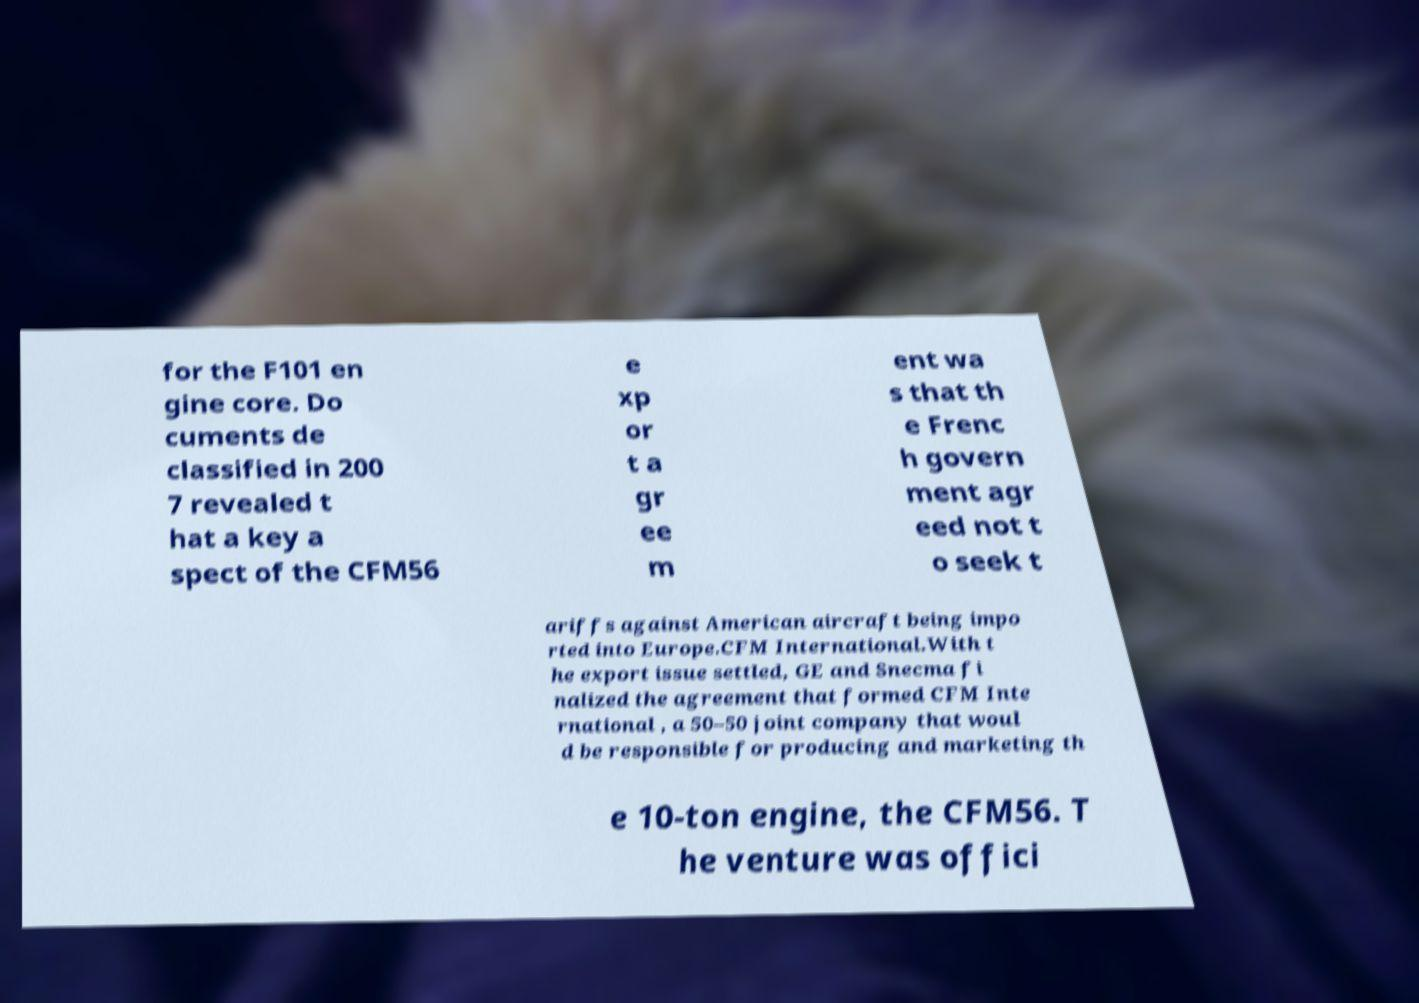Please identify and transcribe the text found in this image. for the F101 en gine core. Do cuments de classified in 200 7 revealed t hat a key a spect of the CFM56 e xp or t a gr ee m ent wa s that th e Frenc h govern ment agr eed not t o seek t ariffs against American aircraft being impo rted into Europe.CFM International.With t he export issue settled, GE and Snecma fi nalized the agreement that formed CFM Inte rnational , a 50–50 joint company that woul d be responsible for producing and marketing th e 10-ton engine, the CFM56. T he venture was offici 